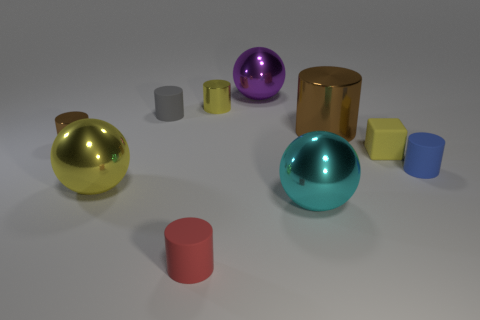How many cylinders are small yellow objects or metallic things?
Provide a succinct answer. 3. Are there any small metallic cylinders?
Offer a very short reply. Yes. What number of other objects are there of the same material as the big yellow object?
Your answer should be compact. 5. What is the material of the brown object that is the same size as the yellow cylinder?
Provide a succinct answer. Metal. Does the small yellow thing that is left of the large purple sphere have the same shape as the red object?
Keep it short and to the point. Yes. How many things are metal balls behind the yellow rubber thing or tiny objects?
Your answer should be very brief. 7. There is a brown thing that is the same size as the purple metal ball; what is its shape?
Keep it short and to the point. Cylinder. There is a brown shiny cylinder that is left of the cyan metallic ball; is its size the same as the metal ball behind the small brown metallic object?
Make the answer very short. No. What is the color of the small cube that is made of the same material as the tiny red cylinder?
Give a very brief answer. Yellow. Do the tiny cylinder that is on the left side of the gray object and the tiny cylinder right of the small rubber cube have the same material?
Your answer should be compact. No. 